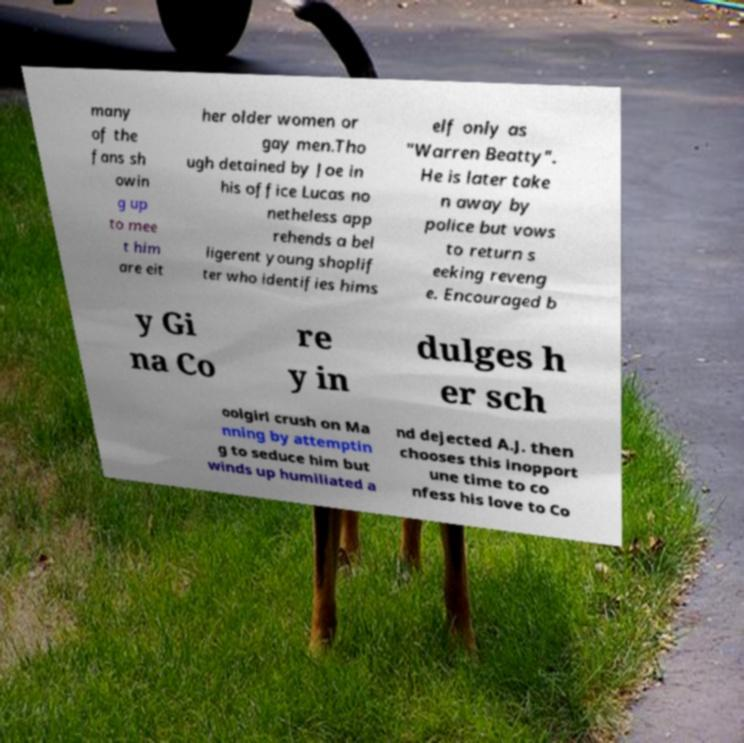Please identify and transcribe the text found in this image. many of the fans sh owin g up to mee t him are eit her older women or gay men.Tho ugh detained by Joe in his office Lucas no netheless app rehends a bel ligerent young shoplif ter who identifies hims elf only as "Warren Beatty". He is later take n away by police but vows to return s eeking reveng e. Encouraged b y Gi na Co re y in dulges h er sch oolgirl crush on Ma nning by attemptin g to seduce him but winds up humiliated a nd dejected A.J. then chooses this inopport une time to co nfess his love to Co 